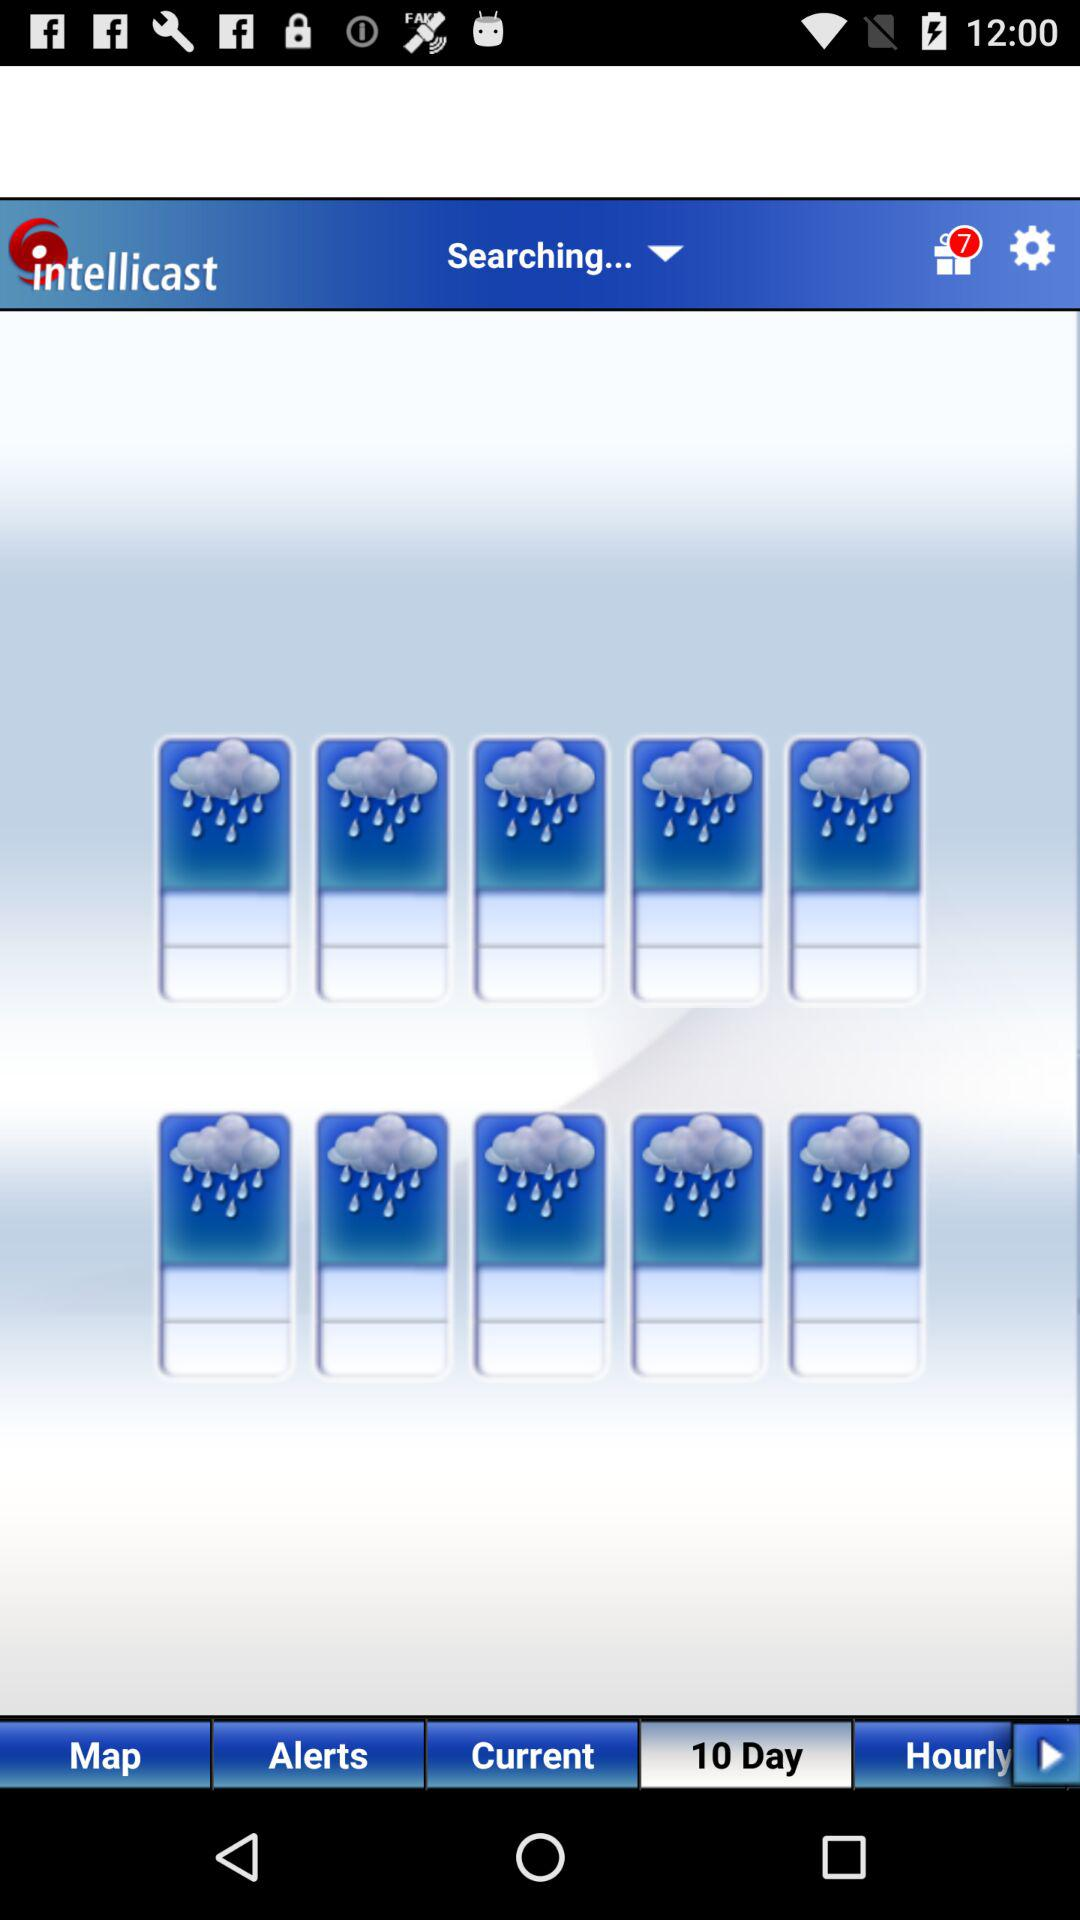What is the name of the application? The name of the application is "intellicast". 